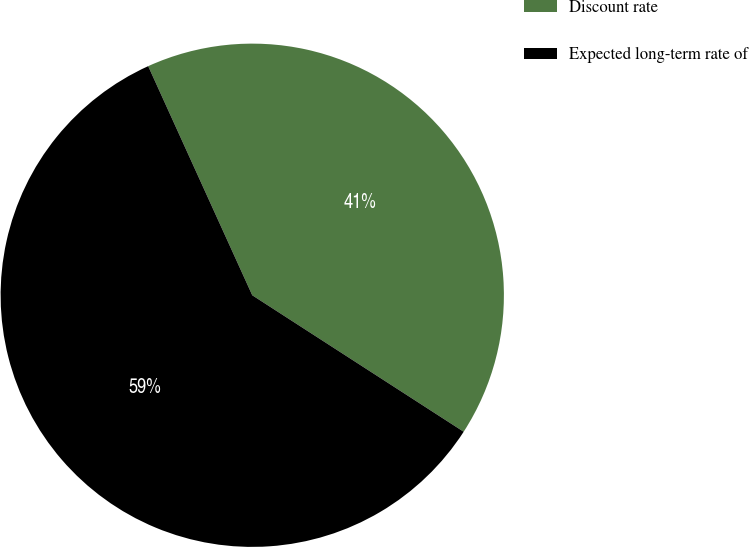Convert chart. <chart><loc_0><loc_0><loc_500><loc_500><pie_chart><fcel>Discount rate<fcel>Expected long-term rate of<nl><fcel>40.91%<fcel>59.09%<nl></chart> 